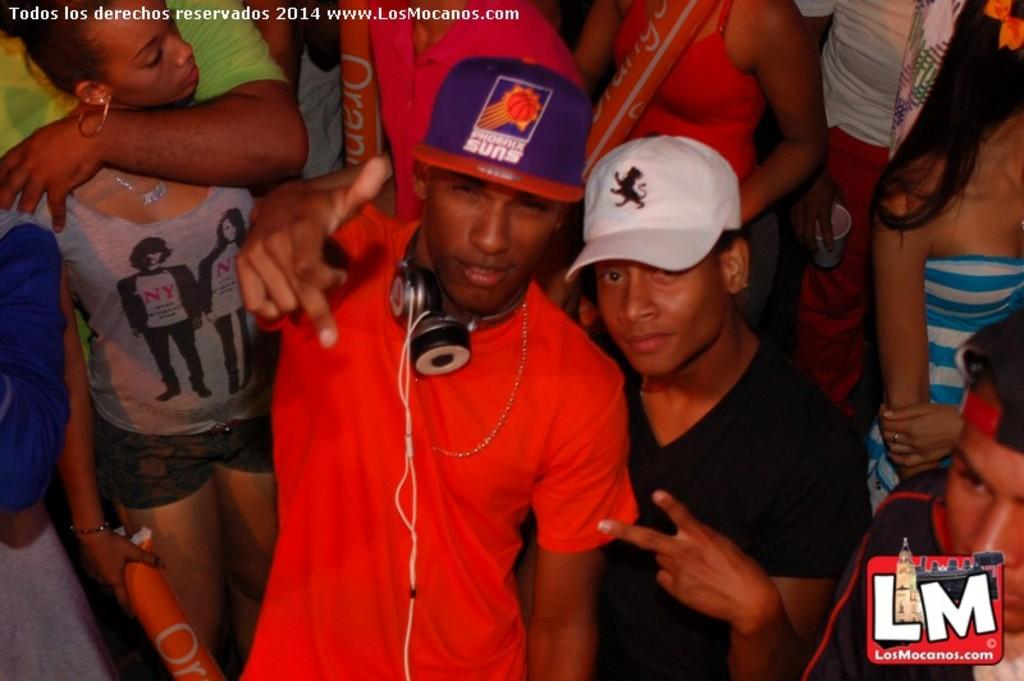What is happening in the image? There are people standing in the image. Can you describe any specific details about the people? A person is wearing headphones around their neck, and some people are holding objects in their hands. What is one of the objects being held by a person in the image? A person is holding a cup. What type of pie is being shared among the people in the image? There is no pie present in the image; the objects being held by the people are not specified. 